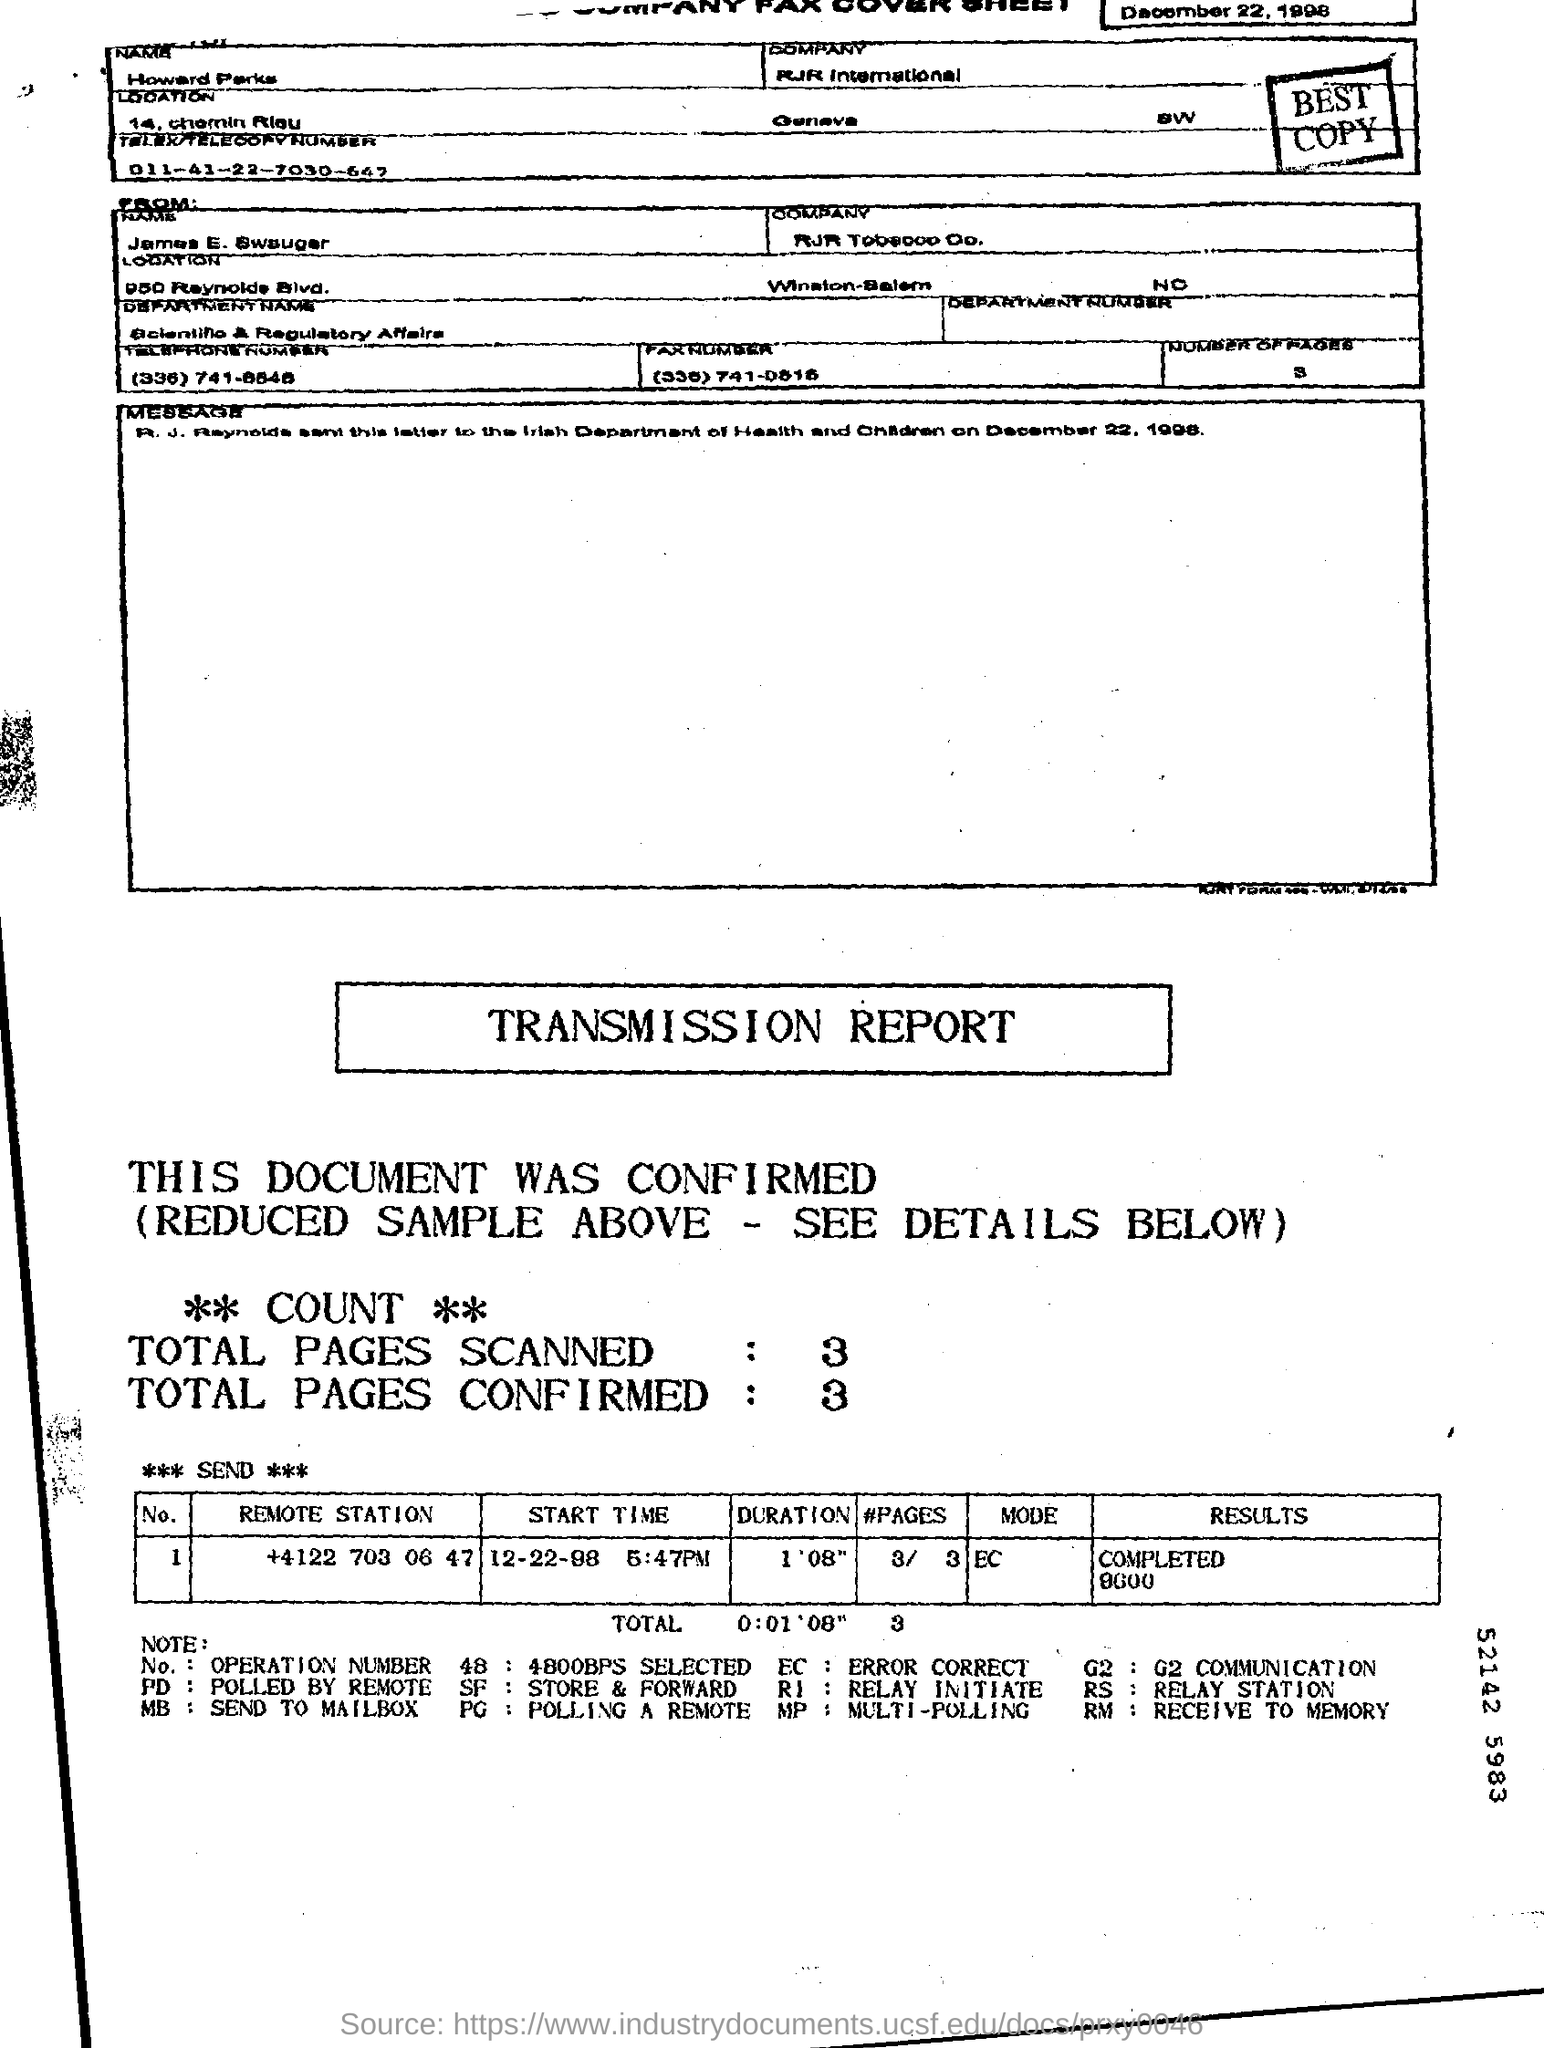What is the Send To "Company"?
Provide a succinct answer. RJR international. What does the code "PG" stand for?
Make the answer very short. Polling a remote. What does the code "EC" stand for?
Make the answer very short. ERROR CORRECT. What is the Date?
Keep it short and to the point. December 22, 1998. What is the "Start Time" for the "Remote Station" "+4122 703 06 47"?
Offer a terse response. 12-22-98 5:47PM. What is the "Duration" for the "Remote Station" "+4122 703 06 47"?
Your answer should be compact. 1 '08". What is the "Results" for the "Remote Station" "+4122 703 06 47"?
Your response must be concise. Completed 9600. What is the "Mode" for the "Remote Station" "+4122 703 06 47"?
Your response must be concise. EC. What are the Total Pages Scanned?
Offer a terse response. 3. What are the Total Pages Confirmed?
Provide a short and direct response. 3. 